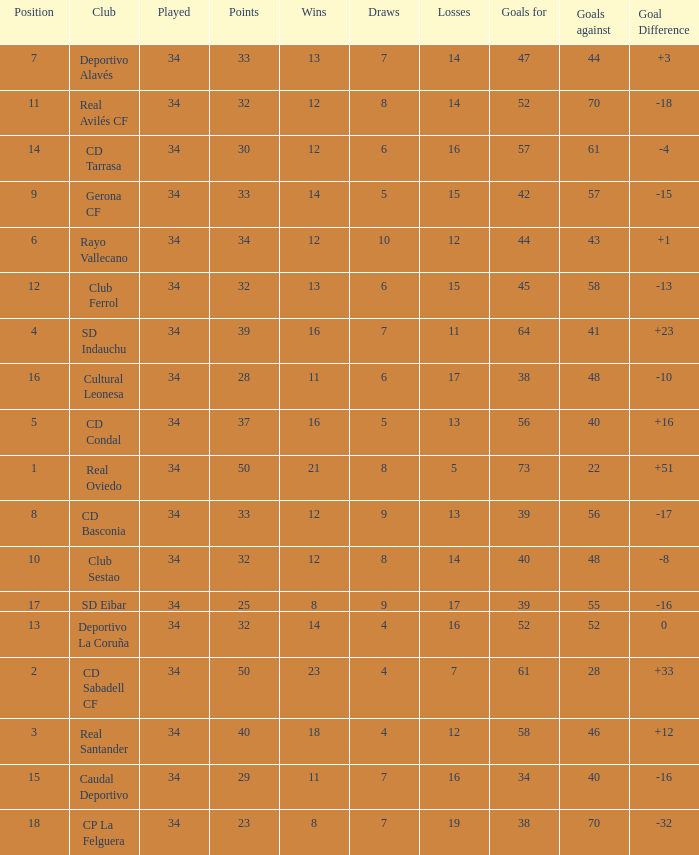Which Wins have a Goal Difference larger than 0, and Goals against larger than 40, and a Position smaller than 6, and a Club of sd indauchu? 16.0. 